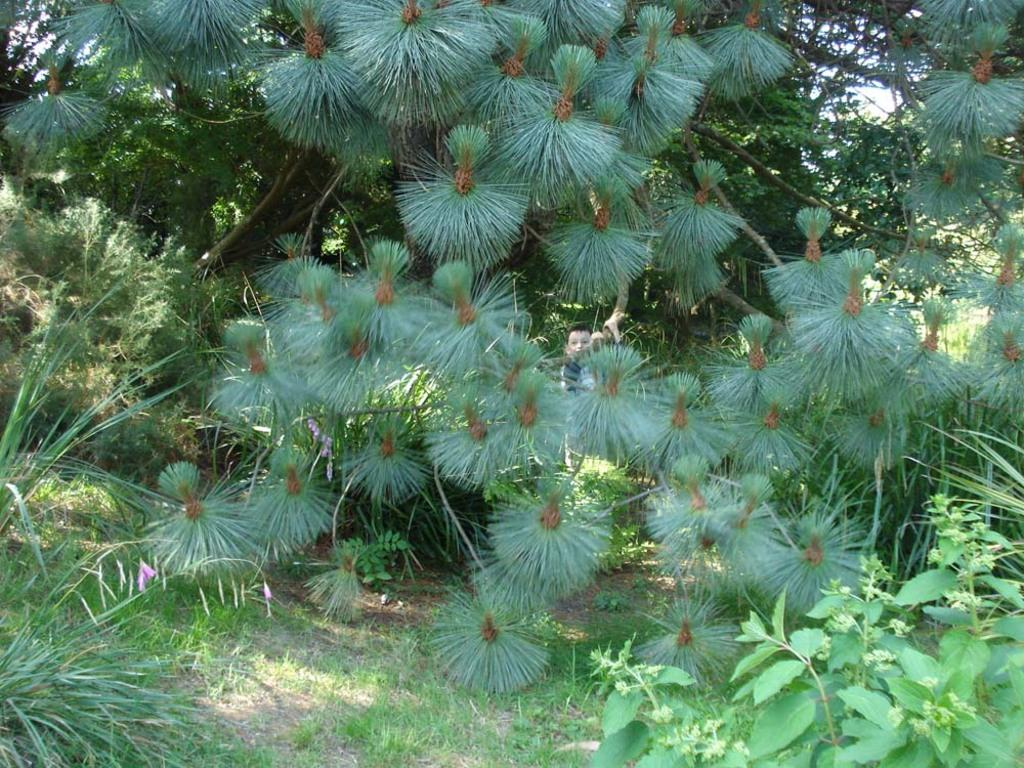What type of vegetation can be seen in the image? There are many plants and trees in the image. Where is the boy located in the image? The boy is in the middle of the image. What is at the bottom of the image? There is grass at the bottom of the image. Reasoning: Let'g: Let's think step by step in order to produce the conversation. We start by identifying the main subjects and objects in the image based on the provided facts. We then formulate questions that focus on the location and characteristics of these subjects and objects, ensuring that each question can be answered definitively with the information given. We avoid yes/no questions and ensure that the language is simple and clear. Absurd Question/Answer: What song is the boy singing in the image? There is no indication in the image that the boy is singing a song. Where can we find a shelf in the image? There is no shelf present in the image. What type of shade is provided by the trees in the image? There is no mention of shade in the image, as it only describes the presence of trees and plants. 